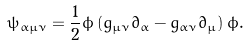<formula> <loc_0><loc_0><loc_500><loc_500>\psi _ { \alpha \mu \nu } = \frac { 1 } { 2 } \phi \left ( g _ { \mu \nu } \partial _ { \alpha } - g _ { \alpha \nu } \partial _ { \mu } \right ) \phi .</formula> 